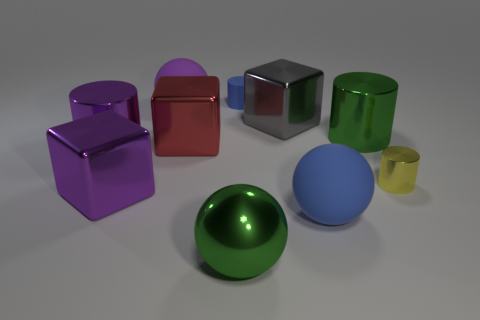Subtract 1 cylinders. How many cylinders are left? 3 Subtract all balls. How many objects are left? 7 Add 6 green metallic objects. How many green metallic objects exist? 8 Subtract 0 brown cubes. How many objects are left? 10 Subtract all green metal objects. Subtract all big metallic cylinders. How many objects are left? 6 Add 7 large purple things. How many large purple things are left? 10 